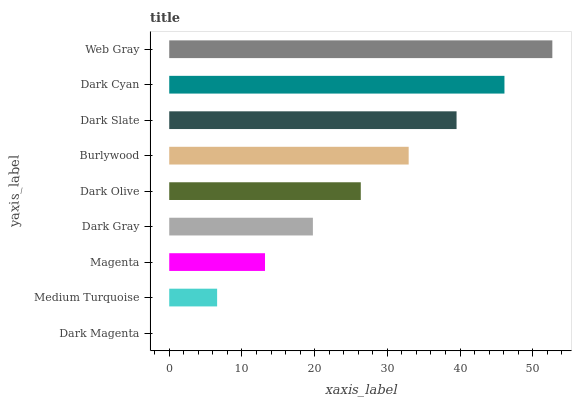Is Dark Magenta the minimum?
Answer yes or no. Yes. Is Web Gray the maximum?
Answer yes or no. Yes. Is Medium Turquoise the minimum?
Answer yes or no. No. Is Medium Turquoise the maximum?
Answer yes or no. No. Is Medium Turquoise greater than Dark Magenta?
Answer yes or no. Yes. Is Dark Magenta less than Medium Turquoise?
Answer yes or no. Yes. Is Dark Magenta greater than Medium Turquoise?
Answer yes or no. No. Is Medium Turquoise less than Dark Magenta?
Answer yes or no. No. Is Dark Olive the high median?
Answer yes or no. Yes. Is Dark Olive the low median?
Answer yes or no. Yes. Is Burlywood the high median?
Answer yes or no. No. Is Web Gray the low median?
Answer yes or no. No. 